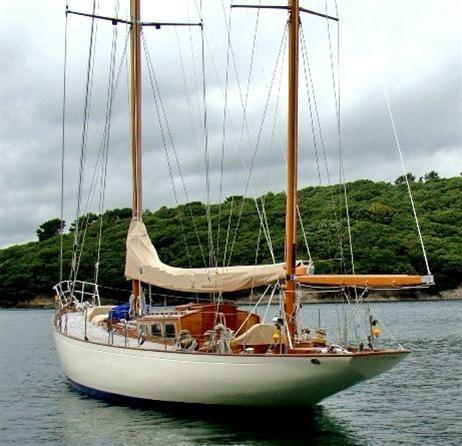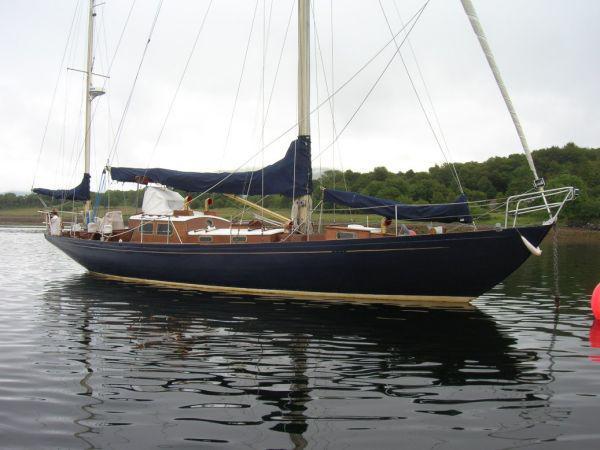The first image is the image on the left, the second image is the image on the right. Evaluate the accuracy of this statement regarding the images: "Trees can be seen in the background of the image on the left.". Is it true? Answer yes or no. Yes. 